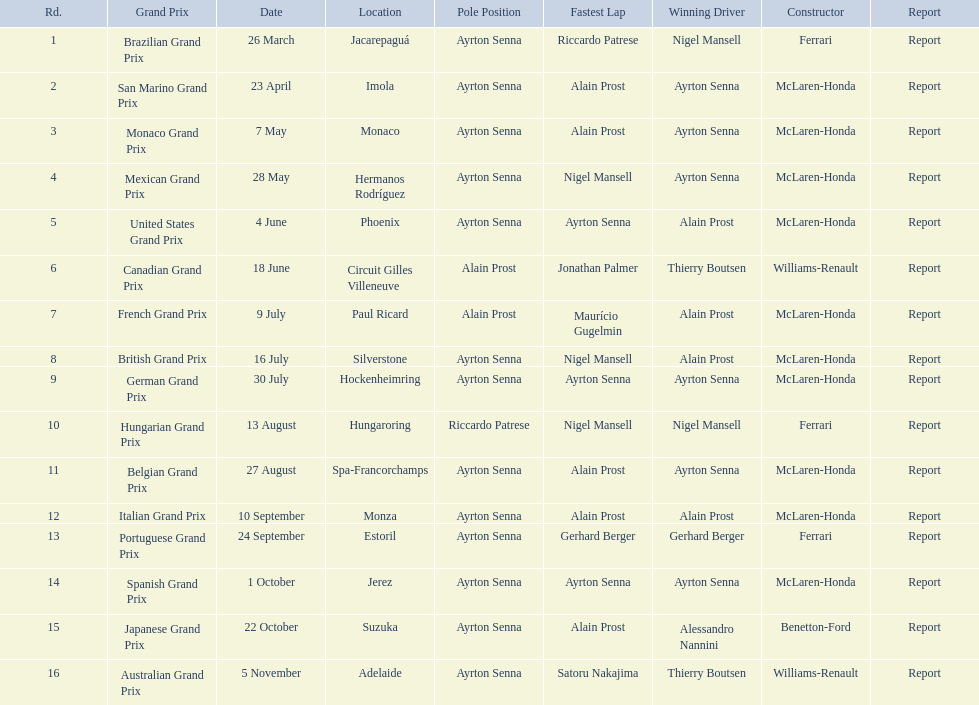Who won the spanish grand prix? McLaren-Honda. Can you give me this table as a dict? {'header': ['Rd.', 'Grand Prix', 'Date', 'Location', 'Pole Position', 'Fastest Lap', 'Winning Driver', 'Constructor', 'Report'], 'rows': [['1', 'Brazilian Grand Prix', '26 March', 'Jacarepaguá', 'Ayrton Senna', 'Riccardo Patrese', 'Nigel Mansell', 'Ferrari', 'Report'], ['2', 'San Marino Grand Prix', '23 April', 'Imola', 'Ayrton Senna', 'Alain Prost', 'Ayrton Senna', 'McLaren-Honda', 'Report'], ['3', 'Monaco Grand Prix', '7 May', 'Monaco', 'Ayrton Senna', 'Alain Prost', 'Ayrton Senna', 'McLaren-Honda', 'Report'], ['4', 'Mexican Grand Prix', '28 May', 'Hermanos Rodríguez', 'Ayrton Senna', 'Nigel Mansell', 'Ayrton Senna', 'McLaren-Honda', 'Report'], ['5', 'United States Grand Prix', '4 June', 'Phoenix', 'Ayrton Senna', 'Ayrton Senna', 'Alain Prost', 'McLaren-Honda', 'Report'], ['6', 'Canadian Grand Prix', '18 June', 'Circuit Gilles Villeneuve', 'Alain Prost', 'Jonathan Palmer', 'Thierry Boutsen', 'Williams-Renault', 'Report'], ['7', 'French Grand Prix', '9 July', 'Paul Ricard', 'Alain Prost', 'Maurício Gugelmin', 'Alain Prost', 'McLaren-Honda', 'Report'], ['8', 'British Grand Prix', '16 July', 'Silverstone', 'Ayrton Senna', 'Nigel Mansell', 'Alain Prost', 'McLaren-Honda', 'Report'], ['9', 'German Grand Prix', '30 July', 'Hockenheimring', 'Ayrton Senna', 'Ayrton Senna', 'Ayrton Senna', 'McLaren-Honda', 'Report'], ['10', 'Hungarian Grand Prix', '13 August', 'Hungaroring', 'Riccardo Patrese', 'Nigel Mansell', 'Nigel Mansell', 'Ferrari', 'Report'], ['11', 'Belgian Grand Prix', '27 August', 'Spa-Francorchamps', 'Ayrton Senna', 'Alain Prost', 'Ayrton Senna', 'McLaren-Honda', 'Report'], ['12', 'Italian Grand Prix', '10 September', 'Monza', 'Ayrton Senna', 'Alain Prost', 'Alain Prost', 'McLaren-Honda', 'Report'], ['13', 'Portuguese Grand Prix', '24 September', 'Estoril', 'Ayrton Senna', 'Gerhard Berger', 'Gerhard Berger', 'Ferrari', 'Report'], ['14', 'Spanish Grand Prix', '1 October', 'Jerez', 'Ayrton Senna', 'Ayrton Senna', 'Ayrton Senna', 'McLaren-Honda', 'Report'], ['15', 'Japanese Grand Prix', '22 October', 'Suzuka', 'Ayrton Senna', 'Alain Prost', 'Alessandro Nannini', 'Benetton-Ford', 'Report'], ['16', 'Australian Grand Prix', '5 November', 'Adelaide', 'Ayrton Senna', 'Satoru Nakajima', 'Thierry Boutsen', 'Williams-Renault', 'Report']]} Who won the italian grand prix? McLaren-Honda. What grand prix did benneton-ford win? Japanese Grand Prix. 